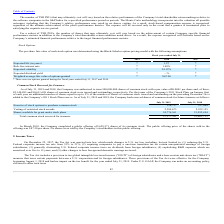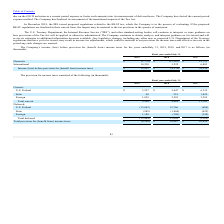From Guidewire Software's financial document, What was the international income (loss) before provision for (benefit from) income taxes in 2019, 2018 and 2017 respectively? The document contains multiple relevant values: 14,230, 5,225, 6,803 (in thousands). From the document: "International 14,230 5,225 6,803 International 14,230 5,225 6,803 International 14,230 5,225 6,803..." Also, What was the Domestic income (loss) before provision for (benefit from) income taxes in 2019, 2018 and 2017 respectively? The document contains multiple relevant values: $(1,778), $(13,501), $21,723 (in thousands). From the document: "Domestic $ (1,778) $ (13,501) $ 21,723 Domestic $ (1,778) $ (13,501) $ 21,723 Domestic $ (1,778) $ (13,501) $ 21,723..." Also, What was the total Income (loss) before provision for (benefit from) income taxes in 2019? According to the financial document, $12,452 (in thousands). The relevant text states: "efore provision for (benefit from) income taxes $ 12,452 $ (8,276) $ 28,526..." Additionally, In which year was International income (loss) before provision for (benefit from) income taxes less than 10,000 thousand? The document shows two values: 2018 and 2017. Locate and analyze international in row 4. From the document: "2019 2018 2017 2019 2018 2017..." Also, can you calculate: What was the average Domestic income (loss) before provision for (benefit from) income taxes for 2019, 2018 and 2017? To answer this question, I need to perform calculations using the financial data. The calculation is: (-1,778 - 13,501 + 21,723) / 3, which equals 2148 (in thousands). This is based on the information: "Domestic $ (1,778) $ (13,501) $ 21,723 Domestic $ (1,778) $ (13,501) $ 21,723 Domestic $ (1,778) $ (13,501) $ 21,723..." The key data points involved are: 1,778, 13,501, 21,723. Also, can you calculate: What is the change in Income (loss) before provision for (benefit from) income taxes between 2017 and 2019? Based on the calculation: 12,452 - 28,526, the result is -16074 (in thousands). This is based on the information: "efore provision for (benefit from) income taxes $ 12,452 $ (8,276) $ 28,526 (benefit from) income taxes $ 12,452 $ (8,276) $ 28,526..." The key data points involved are: 12,452, 28,526. 